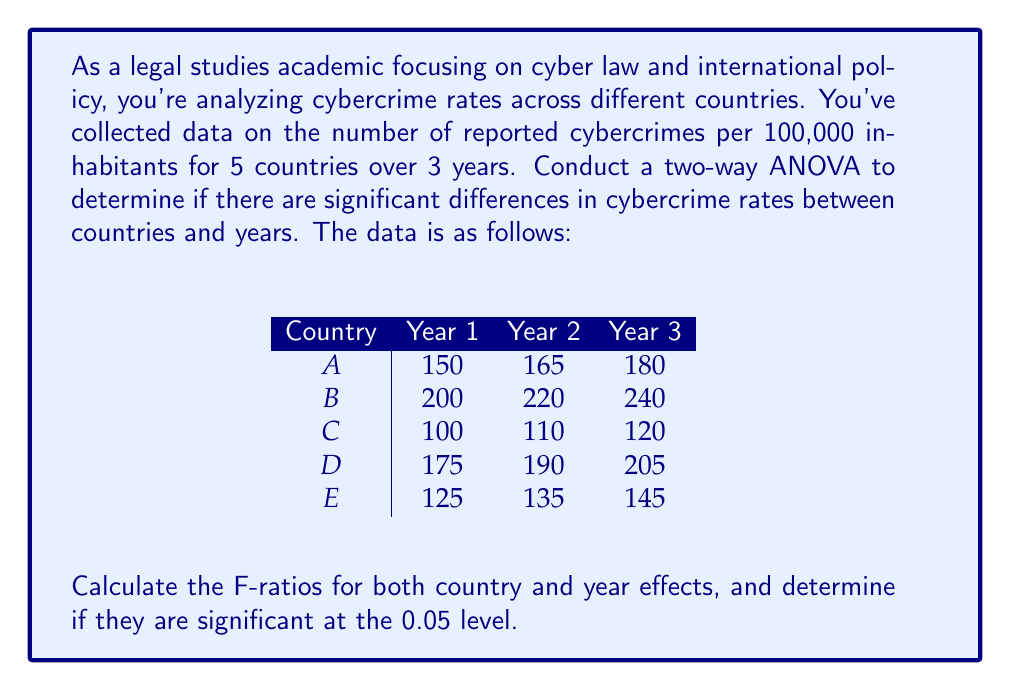Give your solution to this math problem. To conduct a two-way ANOVA, we need to calculate the following:

1. Sum of Squares for Country (SSC)
2. Sum of Squares for Year (SSY)
3. Sum of Squares for Error (SSE)
4. Sum of Squares Total (SST)

Step 1: Calculate the grand mean
$$\bar{X} = \frac{\text{Sum of all values}}{\text{Total number of values}} = \frac{2460}{15} = 164$$

Step 2: Calculate SSC
$$SSC = 3 \sum_{i=1}^{5} (\bar{X_i} - \bar{X})^2$$
Where $\bar{X_i}$ is the mean for each country.
$$SSC = 3[(165-164)^2 + (220-164)^2 + (110-164)^2 + (190-164)^2 + (135-164)^2] = 49,500$$

Step 3: Calculate SSY
$$SSY = 5 \sum_{j=1}^{3} (\bar{X_j} - \bar{X})^2$$
Where $\bar{X_j}$ is the mean for each year.
$$SSY = 5[(150-164)^2 + (164-164)^2 + (178-164)^2] = 2,450$$

Step 4: Calculate SST
$$SST = \sum_{i=1}^{5} \sum_{j=1}^{3} (X_{ij} - \bar{X})^2 = 52,100$$

Step 5: Calculate SSE
$$SSE = SST - SSC - SSY = 52,100 - 49,500 - 2,450 = 150$$

Step 6: Calculate degrees of freedom
$$df_C = 4, df_Y = 2, df_E = 8, df_T = 14$$

Step 7: Calculate Mean Square values
$$MSC = \frac{SSC}{df_C} = \frac{49,500}{4} = 12,375$$
$$MSY = \frac{SSY}{df_Y} = \frac{2,450}{2} = 1,225$$
$$MSE = \frac{SSE}{df_E} = \frac{150}{8} = 18.75$$

Step 8: Calculate F-ratios
$$F_C = \frac{MSC}{MSE} = \frac{12,375}{18.75} = 660$$
$$F_Y = \frac{MSY}{MSE} = \frac{1,225}{18.75} = 65.33$$

Step 9: Compare F-ratios to critical values
At α = 0.05:
F(4,8) critical value ≈ 3.84
F(2,8) critical value ≈ 4.46

Both F-ratios are much larger than their respective critical values, indicating significant effects for both country and year.
Answer: The F-ratio for country effect is 660, and for year effect is 65.33. Both are significant at the 0.05 level, indicating significant differences in cybercrime rates between countries and years. 